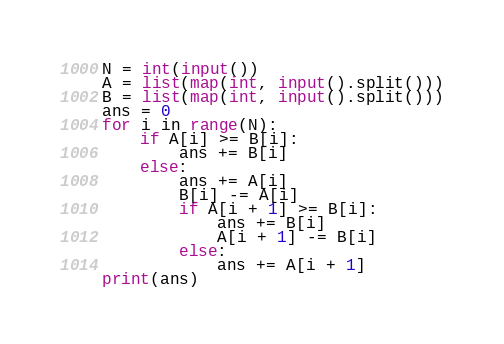<code> <loc_0><loc_0><loc_500><loc_500><_Python_>N = int(input())
A = list(map(int, input().split()))
B = list(map(int, input().split()))
ans = 0
for i in range(N):
    if A[i] >= B[i]:
        ans += B[i]
    else:
        ans += A[i]
        B[i] -= A[i]
        if A[i + 1] >= B[i]:
            ans += B[i]
            A[i + 1] -= B[i]
        else:
            ans += A[i + 1]
print(ans)
</code> 